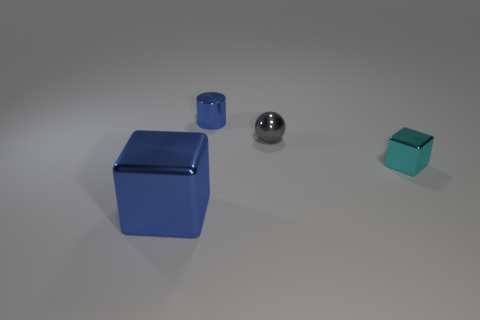Do the objects cast shadows on the surface? Yes, each object casts a shadow on the surface, indicating a source of light in the scene. Can we infer the light source direction based on the shadows? Absolutely. Given the direction and length of the shadows, we can deduce that the light source is coming from the upper left side of the image. 